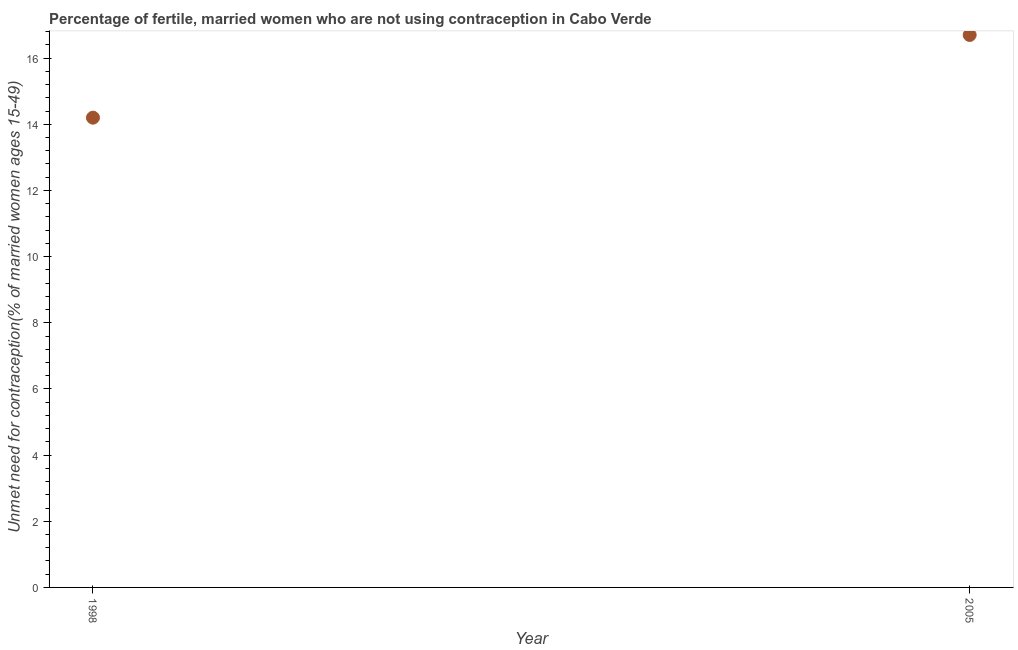Across all years, what is the minimum number of married women who are not using contraception?
Your answer should be compact. 14.2. In which year was the number of married women who are not using contraception minimum?
Keep it short and to the point. 1998. What is the sum of the number of married women who are not using contraception?
Provide a succinct answer. 30.9. What is the average number of married women who are not using contraception per year?
Your answer should be compact. 15.45. What is the median number of married women who are not using contraception?
Provide a succinct answer. 15.45. Do a majority of the years between 2005 and 1998 (inclusive) have number of married women who are not using contraception greater than 11.6 %?
Your response must be concise. No. What is the ratio of the number of married women who are not using contraception in 1998 to that in 2005?
Offer a very short reply. 0.85. Is the number of married women who are not using contraception in 1998 less than that in 2005?
Your answer should be very brief. Yes. In how many years, is the number of married women who are not using contraception greater than the average number of married women who are not using contraception taken over all years?
Your answer should be compact. 1. How many years are there in the graph?
Keep it short and to the point. 2. Does the graph contain any zero values?
Keep it short and to the point. No. Does the graph contain grids?
Keep it short and to the point. No. What is the title of the graph?
Your answer should be very brief. Percentage of fertile, married women who are not using contraception in Cabo Verde. What is the label or title of the X-axis?
Keep it short and to the point. Year. What is the label or title of the Y-axis?
Make the answer very short.  Unmet need for contraception(% of married women ages 15-49). What is the difference between the  Unmet need for contraception(% of married women ages 15-49) in 1998 and 2005?
Offer a very short reply. -2.5. 